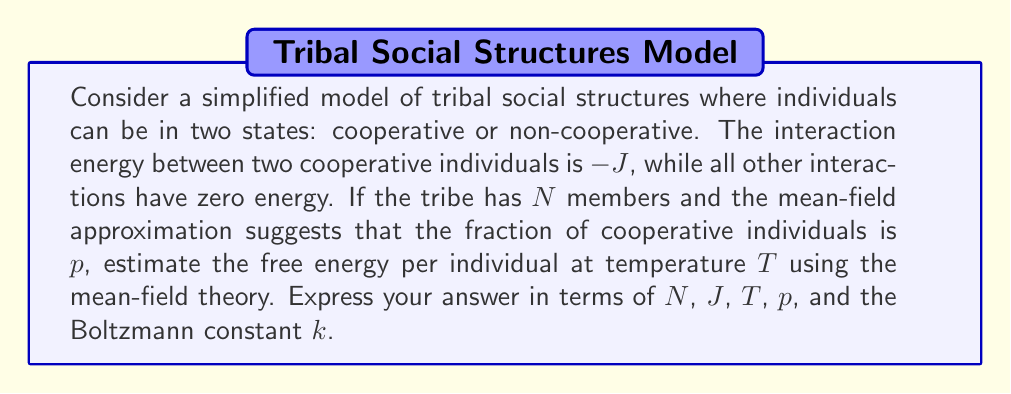Help me with this question. To estimate the free energy using mean-field approximation, we'll follow these steps:

1. Calculate the average energy per individual:
   In the mean-field approximation, each individual interacts with the average field created by all other individuals. The probability of interacting with a cooperative individual is p, so:
   $$E = -\frac{1}{2}NJp^2$$
   The factor 1/2 prevents double-counting of interactions.

2. Calculate the entropy per individual:
   The entropy is given by the mixing entropy of cooperative and non-cooperative individuals:
   $$S = -Nk[p\ln(p) + (1-p)\ln(1-p)]$$

3. Calculate the free energy:
   The free energy F is given by F = E - TS:
   $$F = -\frac{1}{2}NJp^2 + NkT[p\ln(p) + (1-p)\ln(1-p)]$$

4. Express the free energy per individual:
   Divide the total free energy by N:
   $$f = \frac{F}{N} = -\frac{1}{2}Jp^2 + kT[p\ln(p) + (1-p)\ln(1-p)]$$

This expression gives the free energy per individual in terms of N, J, T, p, and k as required.
Answer: $$f = -\frac{1}{2}Jp^2 + kT[p\ln(p) + (1-p)\ln(1-p)]$$ 